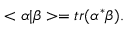Convert formula to latex. <formula><loc_0><loc_0><loc_500><loc_500>< \alpha | \beta > = t r ( \alpha ^ { * } \beta ) .</formula> 